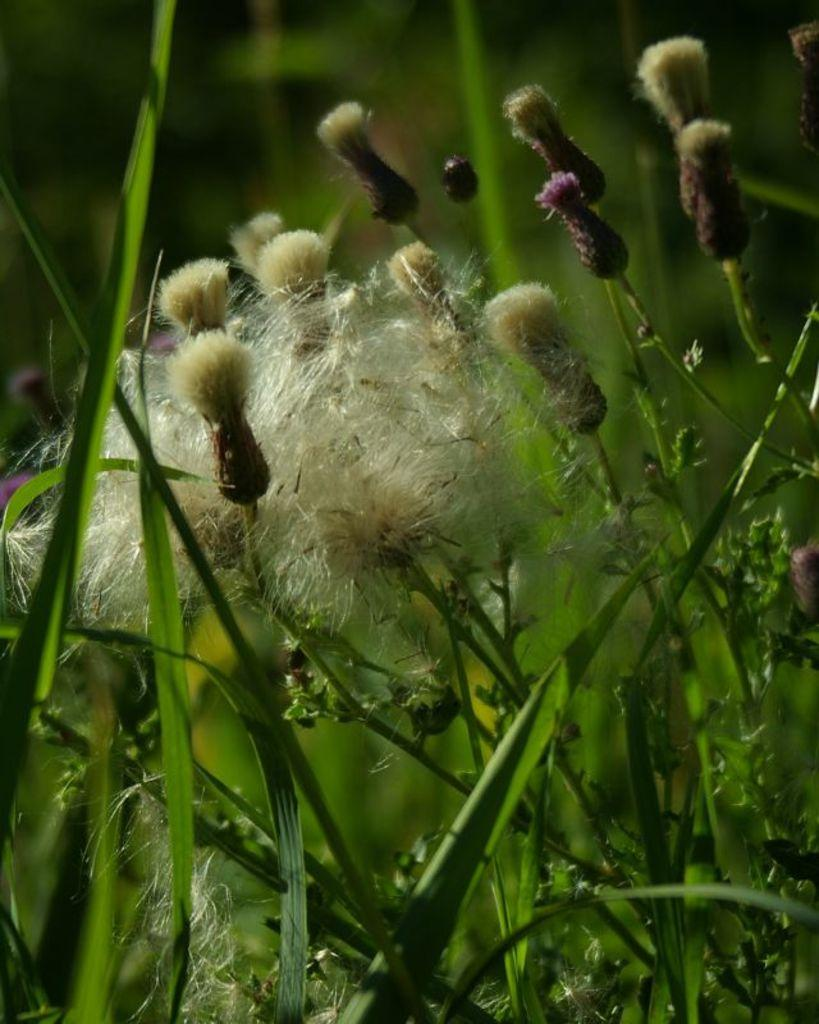What type of vegetation is present in the image? There is grass and plants in the image. What time of day does the image appear to be taken? The image appears to be taken during the day. Can you describe the location based on the vegetation and possible farm setting? The location may be a farm, given the presence of grass and plants. What type of value does the frog bring to the party in the image? There is no frog or party present in the image, so it is not possible to determine any value it might bring. 